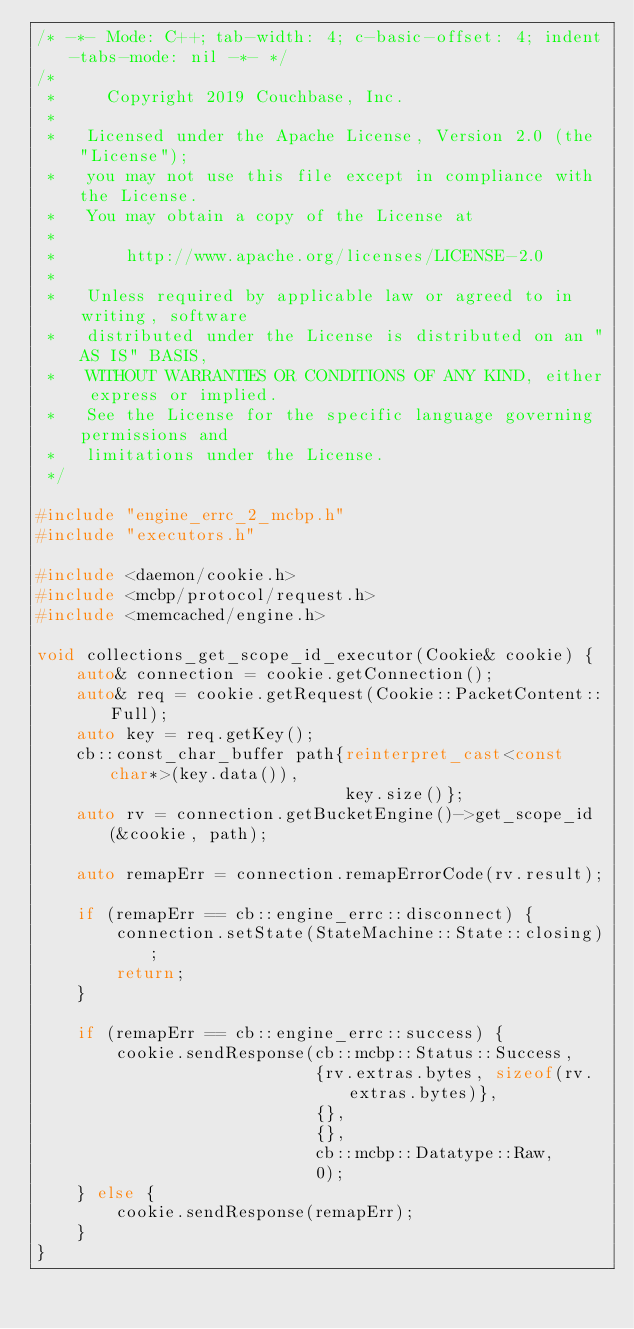Convert code to text. <code><loc_0><loc_0><loc_500><loc_500><_C++_>/* -*- Mode: C++; tab-width: 4; c-basic-offset: 4; indent-tabs-mode: nil -*- */
/*
 *     Copyright 2019 Couchbase, Inc.
 *
 *   Licensed under the Apache License, Version 2.0 (the "License");
 *   you may not use this file except in compliance with the License.
 *   You may obtain a copy of the License at
 *
 *       http://www.apache.org/licenses/LICENSE-2.0
 *
 *   Unless required by applicable law or agreed to in writing, software
 *   distributed under the License is distributed on an "AS IS" BASIS,
 *   WITHOUT WARRANTIES OR CONDITIONS OF ANY KIND, either express or implied.
 *   See the License for the specific language governing permissions and
 *   limitations under the License.
 */

#include "engine_errc_2_mcbp.h"
#include "executors.h"

#include <daemon/cookie.h>
#include <mcbp/protocol/request.h>
#include <memcached/engine.h>

void collections_get_scope_id_executor(Cookie& cookie) {
    auto& connection = cookie.getConnection();
    auto& req = cookie.getRequest(Cookie::PacketContent::Full);
    auto key = req.getKey();
    cb::const_char_buffer path{reinterpret_cast<const char*>(key.data()),
                               key.size()};
    auto rv = connection.getBucketEngine()->get_scope_id(&cookie, path);

    auto remapErr = connection.remapErrorCode(rv.result);

    if (remapErr == cb::engine_errc::disconnect) {
        connection.setState(StateMachine::State::closing);
        return;
    }

    if (remapErr == cb::engine_errc::success) {
        cookie.sendResponse(cb::mcbp::Status::Success,
                            {rv.extras.bytes, sizeof(rv.extras.bytes)},
                            {},
                            {},
                            cb::mcbp::Datatype::Raw,
                            0);
    } else {
        cookie.sendResponse(remapErr);
    }
}
</code> 